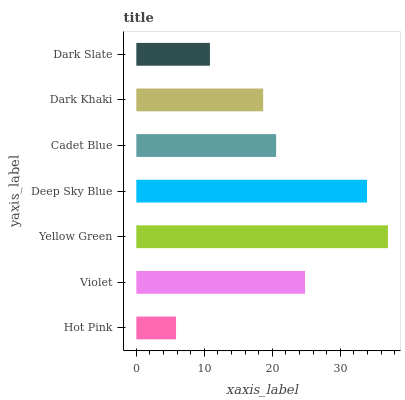Is Hot Pink the minimum?
Answer yes or no. Yes. Is Yellow Green the maximum?
Answer yes or no. Yes. Is Violet the minimum?
Answer yes or no. No. Is Violet the maximum?
Answer yes or no. No. Is Violet greater than Hot Pink?
Answer yes or no. Yes. Is Hot Pink less than Violet?
Answer yes or no. Yes. Is Hot Pink greater than Violet?
Answer yes or no. No. Is Violet less than Hot Pink?
Answer yes or no. No. Is Cadet Blue the high median?
Answer yes or no. Yes. Is Cadet Blue the low median?
Answer yes or no. Yes. Is Yellow Green the high median?
Answer yes or no. No. Is Yellow Green the low median?
Answer yes or no. No. 